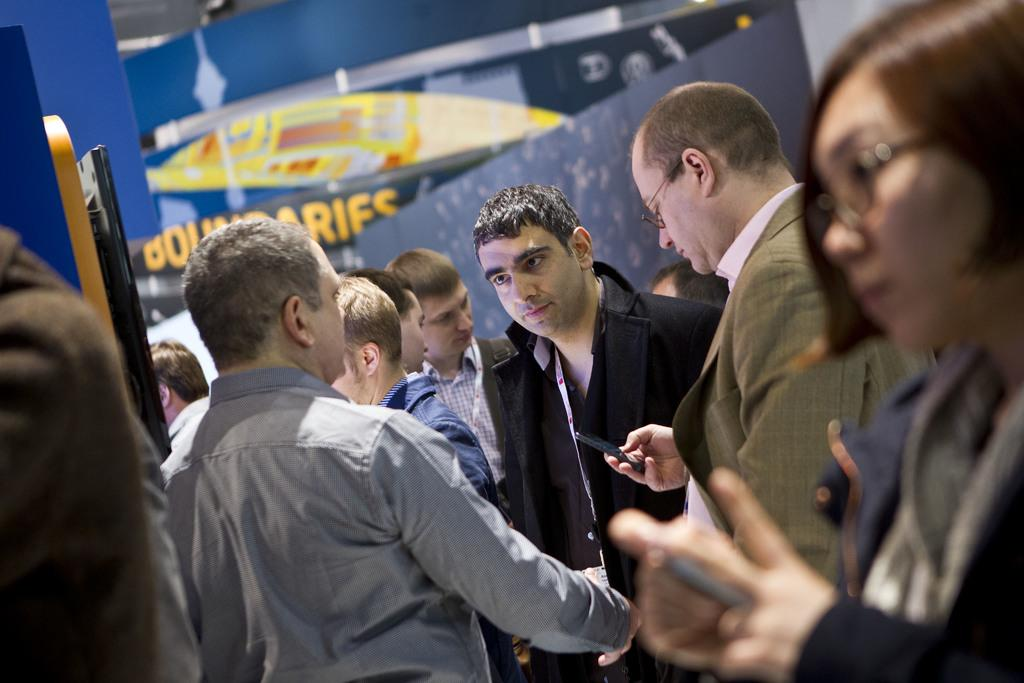What are the people in the image doing? The people in the image are standing in the center. What are some of the people holding in the image? Some people are holding objects in the image. What can be seen in the background of the image? There is a wall and banners in the background of the image, along with other unspecified objects. What type of doctor is present in the image? There is no doctor present in the image. How does the image make you feel? The image itself does not evoke a specific feeling, as it is a static representation of people and objects. 